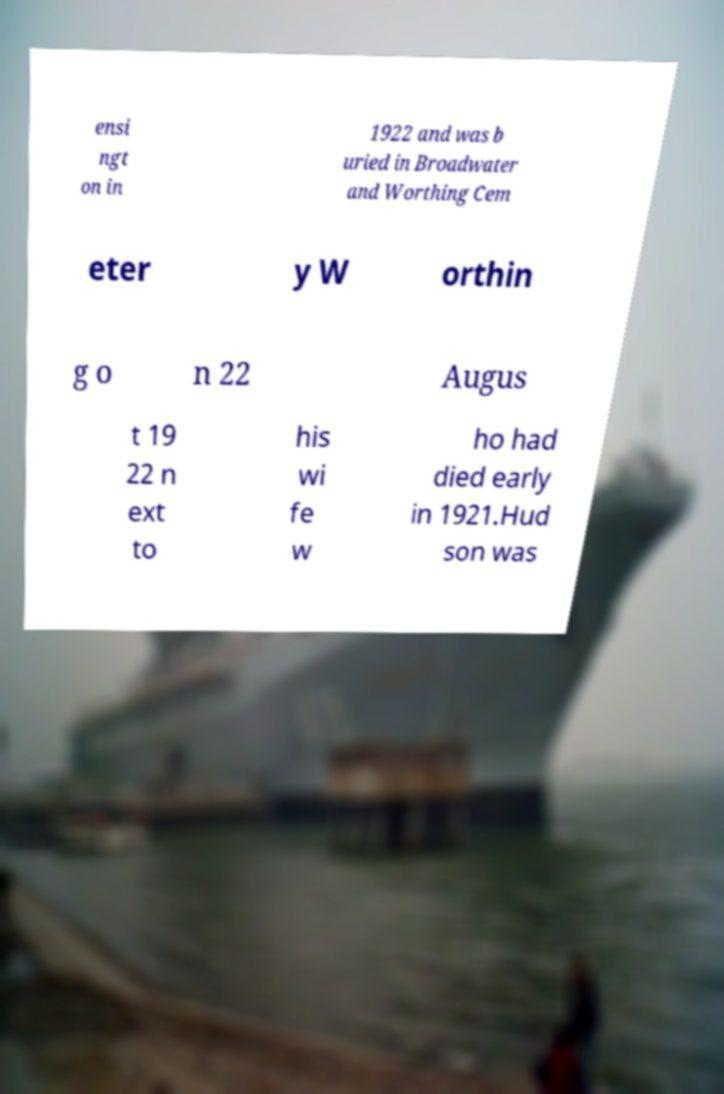Can you read and provide the text displayed in the image?This photo seems to have some interesting text. Can you extract and type it out for me? ensi ngt on in 1922 and was b uried in Broadwater and Worthing Cem eter y W orthin g o n 22 Augus t 19 22 n ext to his wi fe w ho had died early in 1921.Hud son was 